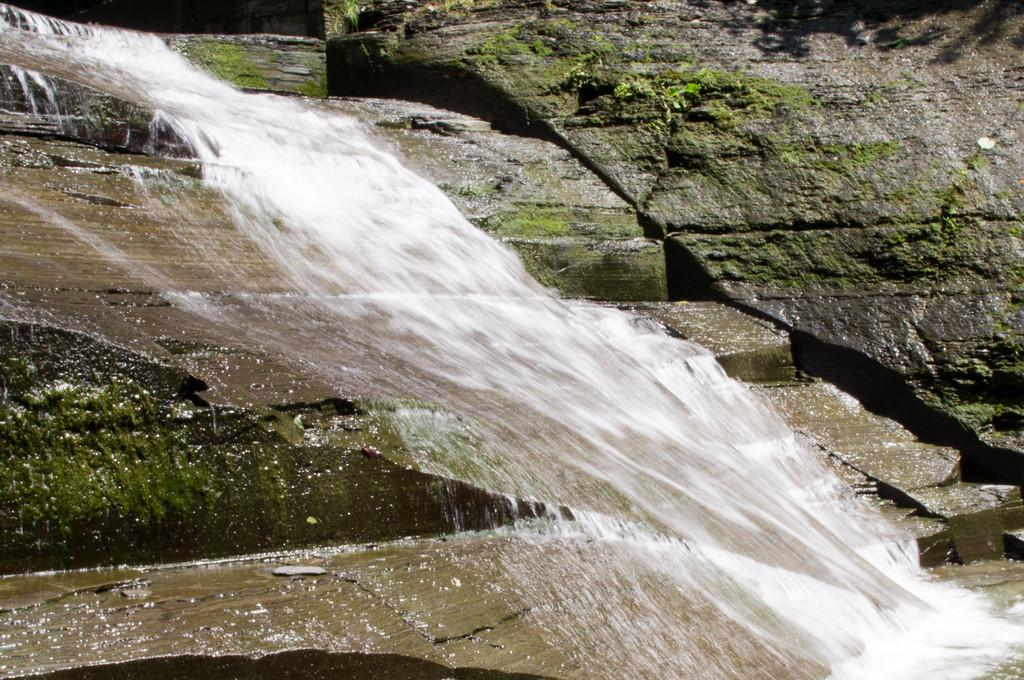What is happening in the image? Water is flowing in the image. What is the water flowing over? The water is flowing over rocks. What can be seen in the background of the image? There are rocks and a staircase visible in the background of the image. What type of art can be seen hanging on the walls of the farm in the image? There is no farm or art present in the image; it features water flowing over rocks with rocks and a staircase visible in the background. 